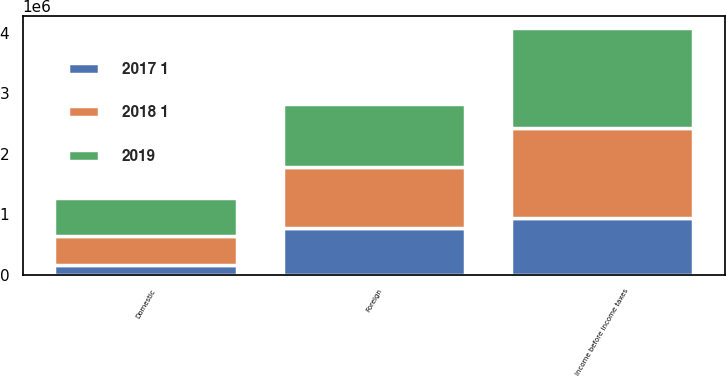<chart> <loc_0><loc_0><loc_500><loc_500><stacked_bar_chart><ecel><fcel>Domestic<fcel>Foreign<fcel>Income before income taxes<nl><fcel>2018 1<fcel>484876<fcel>1.00085e+06<fcel>1.48573e+06<nl><fcel>2019<fcel>615238<fcel>1.04008e+06<fcel>1.65531e+06<nl><fcel>2017 1<fcel>161248<fcel>773499<fcel>934747<nl></chart> 